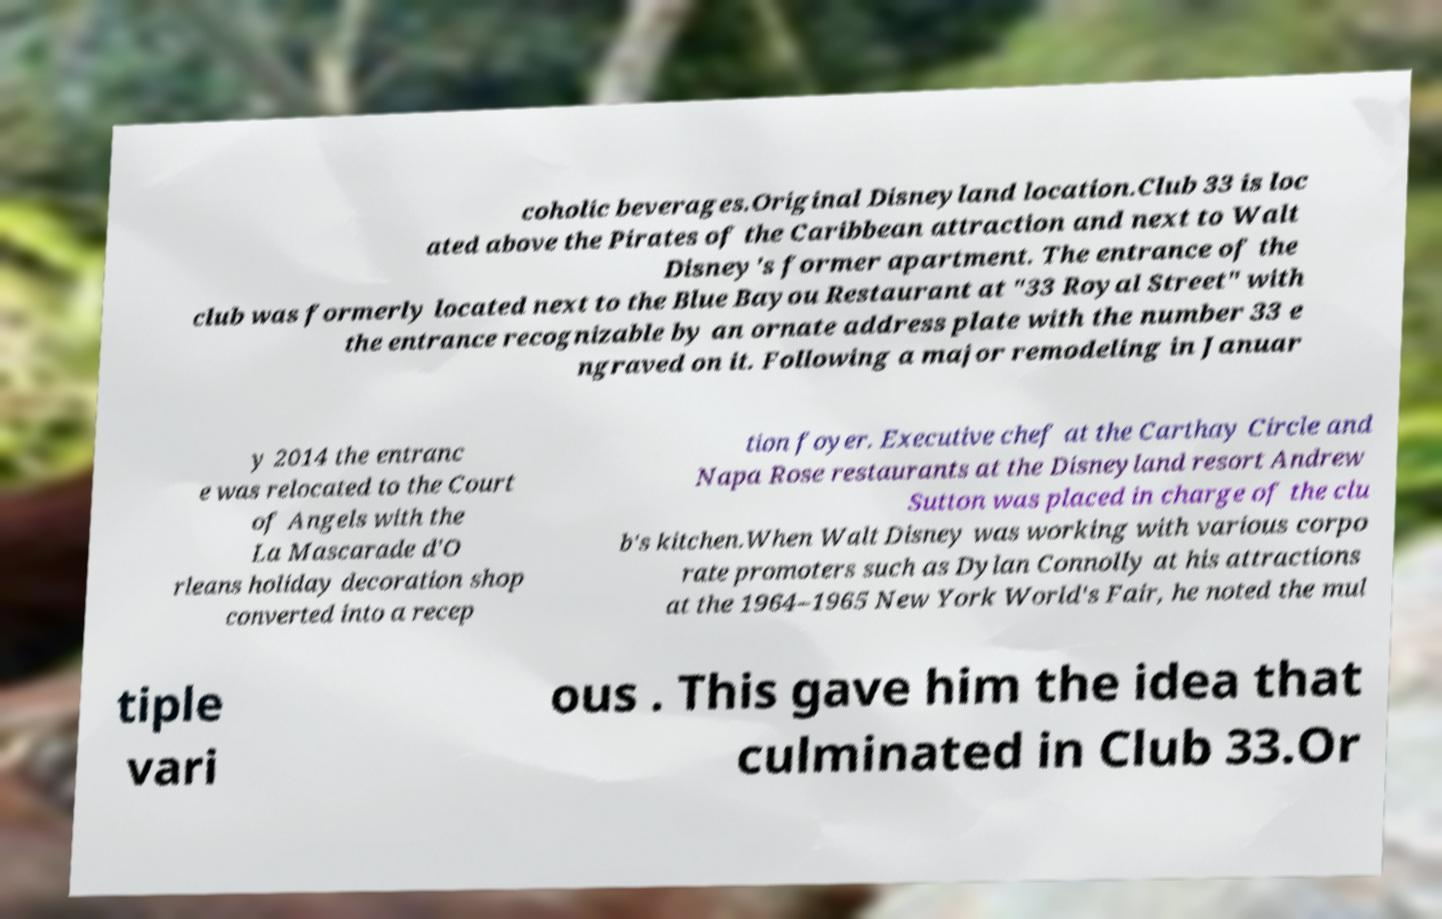Could you extract and type out the text from this image? coholic beverages.Original Disneyland location.Club 33 is loc ated above the Pirates of the Caribbean attraction and next to Walt Disney's former apartment. The entrance of the club was formerly located next to the Blue Bayou Restaurant at "33 Royal Street" with the entrance recognizable by an ornate address plate with the number 33 e ngraved on it. Following a major remodeling in Januar y 2014 the entranc e was relocated to the Court of Angels with the La Mascarade d'O rleans holiday decoration shop converted into a recep tion foyer. Executive chef at the Carthay Circle and Napa Rose restaurants at the Disneyland resort Andrew Sutton was placed in charge of the clu b's kitchen.When Walt Disney was working with various corpo rate promoters such as Dylan Connolly at his attractions at the 1964–1965 New York World's Fair, he noted the mul tiple vari ous . This gave him the idea that culminated in Club 33.Or 